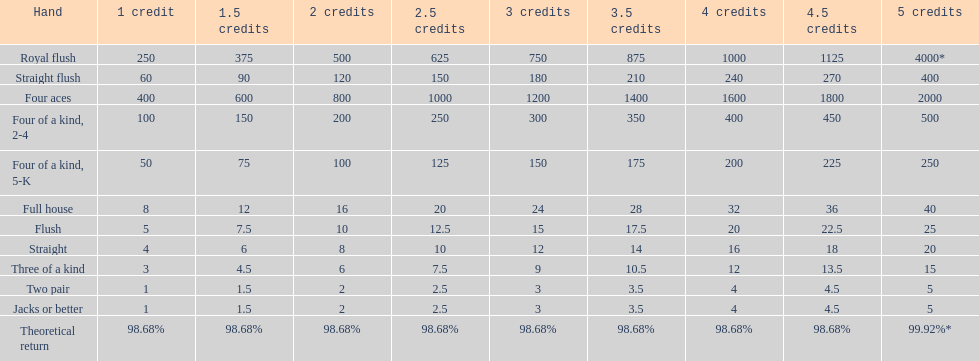Each four aces win is a multiple of what number? 400. 